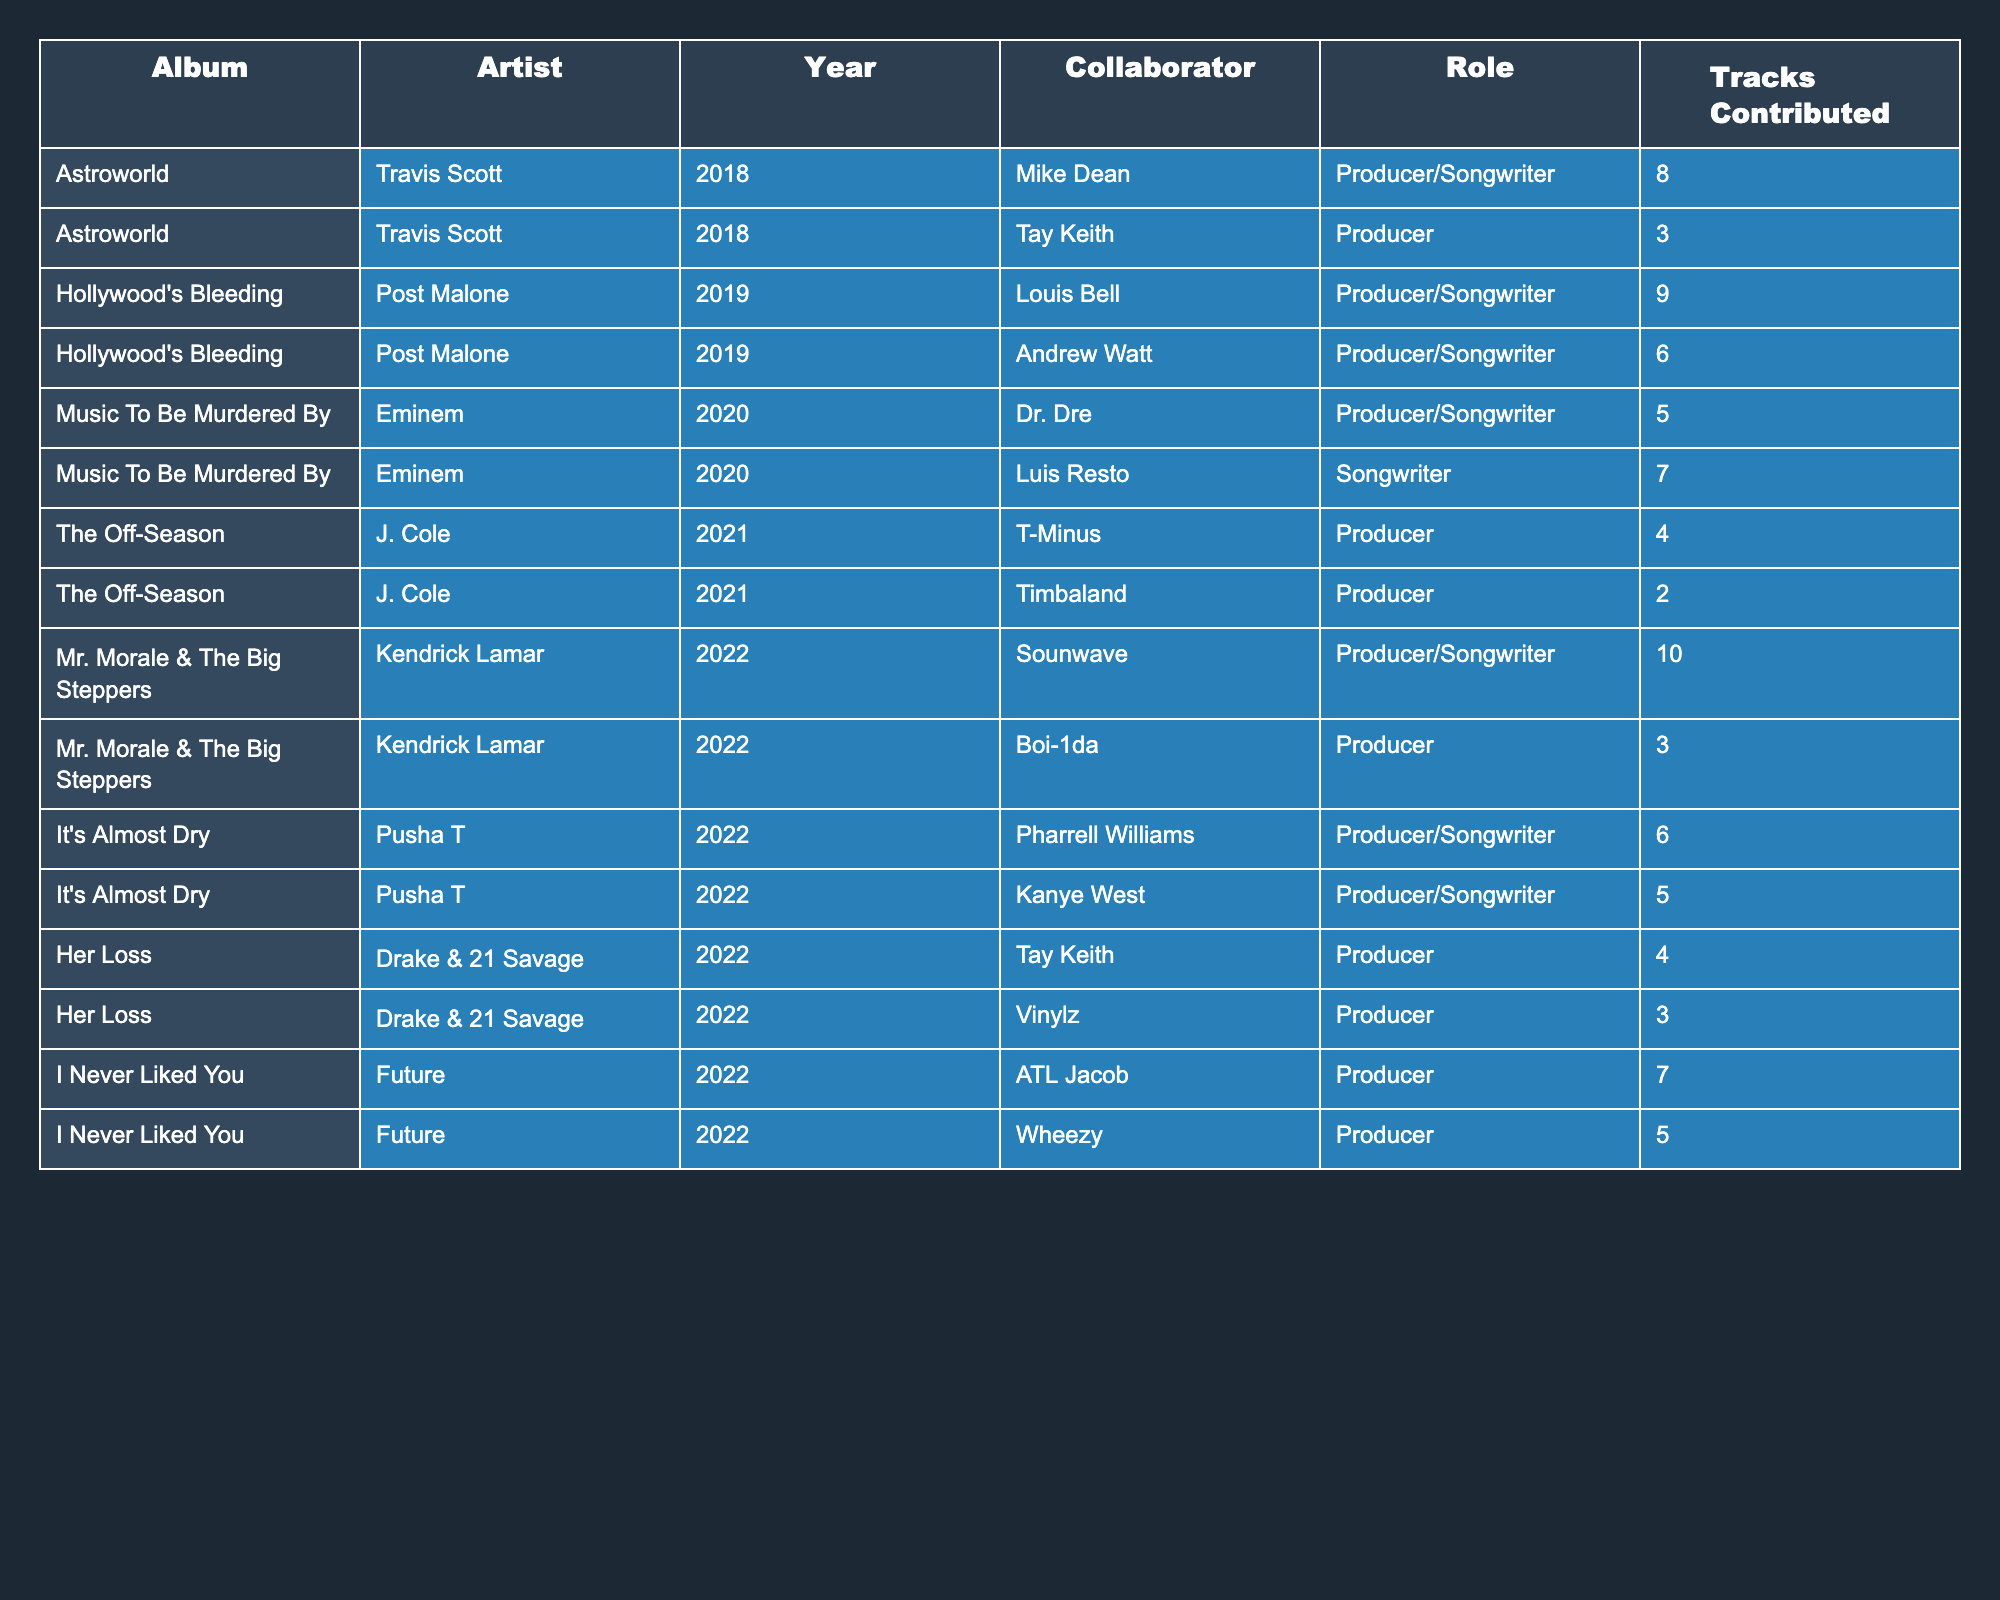What album features the most collaborators? "Mr. Morale & The Big Steppers" has 2 collaborators listed, the same as "It's Almost Dry," but since it has more total tracks contributed (10 vs. 11), it’s the one with the most collaboration effort.
Answer: "Mr. Morale & The Big Steppers" Which collaborator contributed to the most tracks overall? Sounwave contributed to 10 tracks for "Mr. Morale & The Big Steppers," which is the highest among all collaborators listed in the table.
Answer: 10 Did any albums have multiple roles for the same collaborator? Yes, in "Astroworld," Mike Dean contributed as both Producer and Songwriter.
Answer: Yes What is the total number of tracks contributed across all platinum-certified rap albums in this table? We sum all the tracks contributed: 8 + 3 + 9 + 6 + 5 + 7 + 4 + 2 + 10 + 3 + 6 + 5 + 4 + 3 + 7 + 5 = 81 tracks contributed.
Answer: 81 Which artist collaborated with the most producers for their album? Post Malone collaborated with 2 producers (Louis Bell and Andrew Watt) in "Hollywood's Bleeding," which is the highest among any artist listed.
Answer: 2 Is there a collaborator who worked alongside more than one artist? Yes, Tay Keith worked as a producer for both Travis Scott in "Astroworld" and for Drake & 21 Savage in "Her Loss."
Answer: Yes How many different roles were the collaborators involved in? There are three roles listed: Producer, Songwriter, and Producer/Songwriter.
Answer: 3 What is the average number of tracks contributed per album? There are 16 total contributions across 10 albums. Hence, the average is 81/10 = 8.1 tracks per album.
Answer: 8.1 Was there any collaboration that involved Kanye West? Yes, Kanye West was a Producer/Songwriter for Pusha T’s album "It's Almost Dry."
Answer: Yes Which album had the least number of tracks contributed to it? "The Off-Season" had the least tracks, with a total of 6 tracks contributed.
Answer: 6 What is the total number of different collaborators across all albums? Five individuals contributed as producers, three as songwriters, totaling 7 unique collaborators.
Answer: 7 